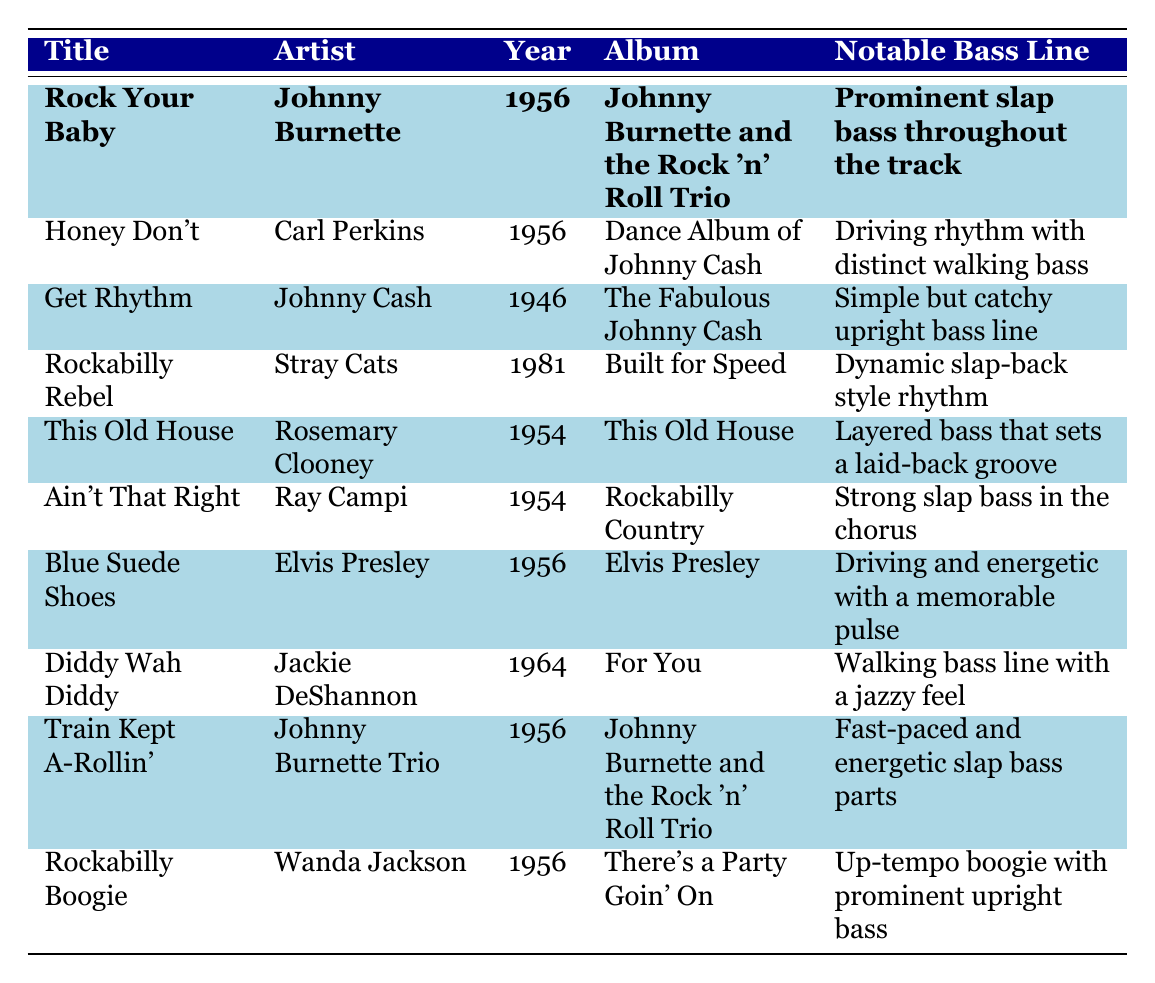What is the title of the song by Johnny Cash? The table shows that Johnny Cash's song is **Get Rhythm** from the year **1946**.
Answer: Get Rhythm Which artist performed **Blue Suede Shoes**? According to the table, the artist for the song **Blue Suede Shoes** is **Elvis Presley**.
Answer: Elvis Presley How many songs were released in **1956**? By examining the table, we see that there are **5 songs** (Rock Your Baby, Honey Don't, Blue Suede Shoes, Train Kept A-Rollin', and Rockabilly Boogie) released in the year **1956**.
Answer: 5 Which song has a driving rhythm with distinct walking bass? The table indicates that **Honey Don't** by **Carl Perkins** features a **driving rhythm with distinct walking bass**.
Answer: Honey Don't Is **Diddy Wah Diddy** by Jackie DeShannon? Yes, the table confirms that **Diddy Wah Diddy** is indeed performed by **Jackie DeShannon**.
Answer: Yes Which artist has the most songs listed in the table? Upon reviewing the table, **Johnny Burnette** appears twice (in Rock Your Baby and Train Kept A-Rollin'), while other artists appear only once. Therefore, Johnny Burnette has the most songs listed.
Answer: Johnny Burnette What is the notable bass line in **Rockabilly Boogie**? The notable bass line for **Rockabilly Boogie** is described as **up-tempo boogie with prominent upright bass** in the table.
Answer: Up-tempo boogie with prominent upright bass What year did **Stray Cats** release their song? The table shows that **Rockabilly Rebel** by **Stray Cats** was released in **1981**.
Answer: 1981 Which songs have slap bass as a notable feature? The songs that have slap bass noted in the table include **Rock Your Baby**, **Ain't That Right**, **Rockabilly Rebel**, **Train Kept A-Rollin'**, and **Rockabilly Boogie**. That's a total of **5 songs**.
Answer: 5 songs What is the average release year of the songs listed? The years for the songs are 1946, 1954, 1954, 1956, 1956, 1956, 1956, 1964, and 1981. Summing these gives 1946 + 1954 + 1954 + 1956 + 1956 + 1956 + 1956 + 1964 + 1981 = 1735, and dividing by the number of songs (9) gives an average year of **192.78**, approximately **1956**.
Answer: 1956 Which album features the song **Get Rhythm**? According to the table, **Get Rhythm** is from the album **The Fabulous Johnny Cash**.
Answer: The Fabulous Johnny Cash 